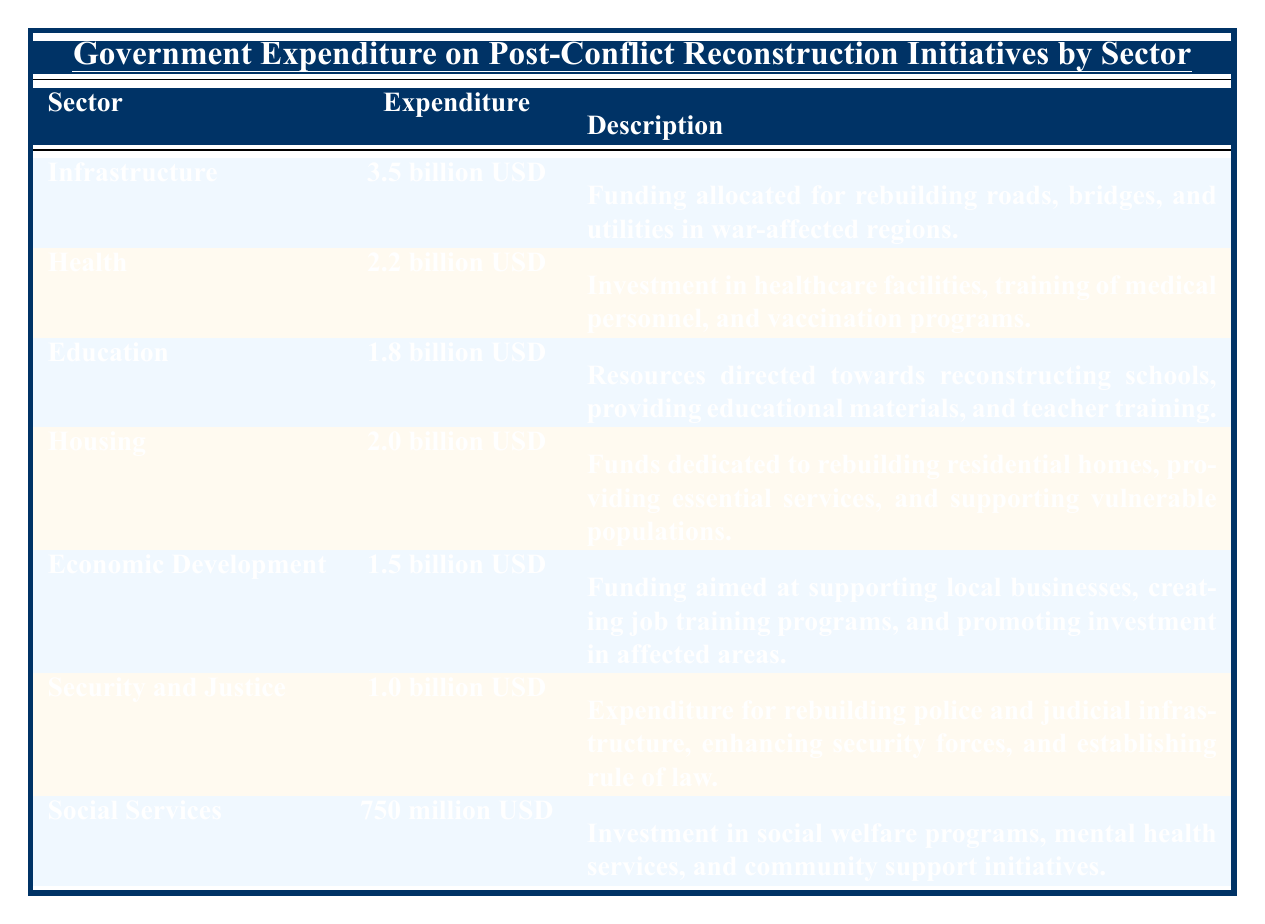What is the total government expenditure on post-conflict reconstruction initiatives? By adding all the government expenditure amounts from each sector: 3.5 billion + 2.2 billion + 1.8 billion + 2.0 billion + 1.5 billion + 1.0 billion + 0.75 billion = 12.75 billion USD
Answer: 12.75 billion USD Which sector received the highest expenditure? The sector with the highest expenditure is Infrastructure with 3.5 billion USD allocated to it
Answer: Infrastructure What is the expenditure amount for Social Services? The expenditure amount for Social Services is 750 million USD as shown in the table
Answer: 750 million USD How much more was spent on Health compared to Education? To find the difference, subtract the expenditure of Education from Health: 2.2 billion - 1.8 billion = 0.4 billion USD. Therefore, 400 million USD more was spent on Health
Answer: 400 million USD Is the expenditure on Economic Development less than the expenditure on Housing? Yes, Economic Development has an expenditure of 1.5 billion USD, which is less than Housing's expenditure of 2.0 billion USD
Answer: Yes What is the average expenditure per sector for the reconstruction initiatives? To find the average, divide the total expenditure by the number of sectors: Total expenditure is 12.75 billion USD, and there are 7 sectors. So, 12.75 billion / 7 = 1.822 billion USD approximately
Answer: 1.822 billion USD If we only consider the top three sectors by expenditure, what would be their total? The top three sectors are Infrastructure (3.5 billion), Health (2.2 billion), and Housing (2.0 billion). Adding these: 3.5 billion + 2.2 billion + 2.0 billion = 7.7 billion USD
Answer: 7.7 billion USD What percentage of the total reconstruction expenditure is allocated to Security and Justice? The percentage is calculated by dividing the expenditure for Security and Justice by the total expenditure, and then multiplying by 100: (1.0 billion / 12.75 billion) * 100 ≈ 7.84%. This indicates that about 7.84% of the total expenditure goes to Security and Justice
Answer: 7.84% Which two sectors combined received less than the expenditure for Infrastructure? The sectors of Social Services (750 million USD) and Economic Development (1.5 billion USD) together receive 750 million + 1.5 billion = 2.25 billion USD, which is less than Infrastructure's 3.5 billion USD
Answer: Social Services and Economic Development 